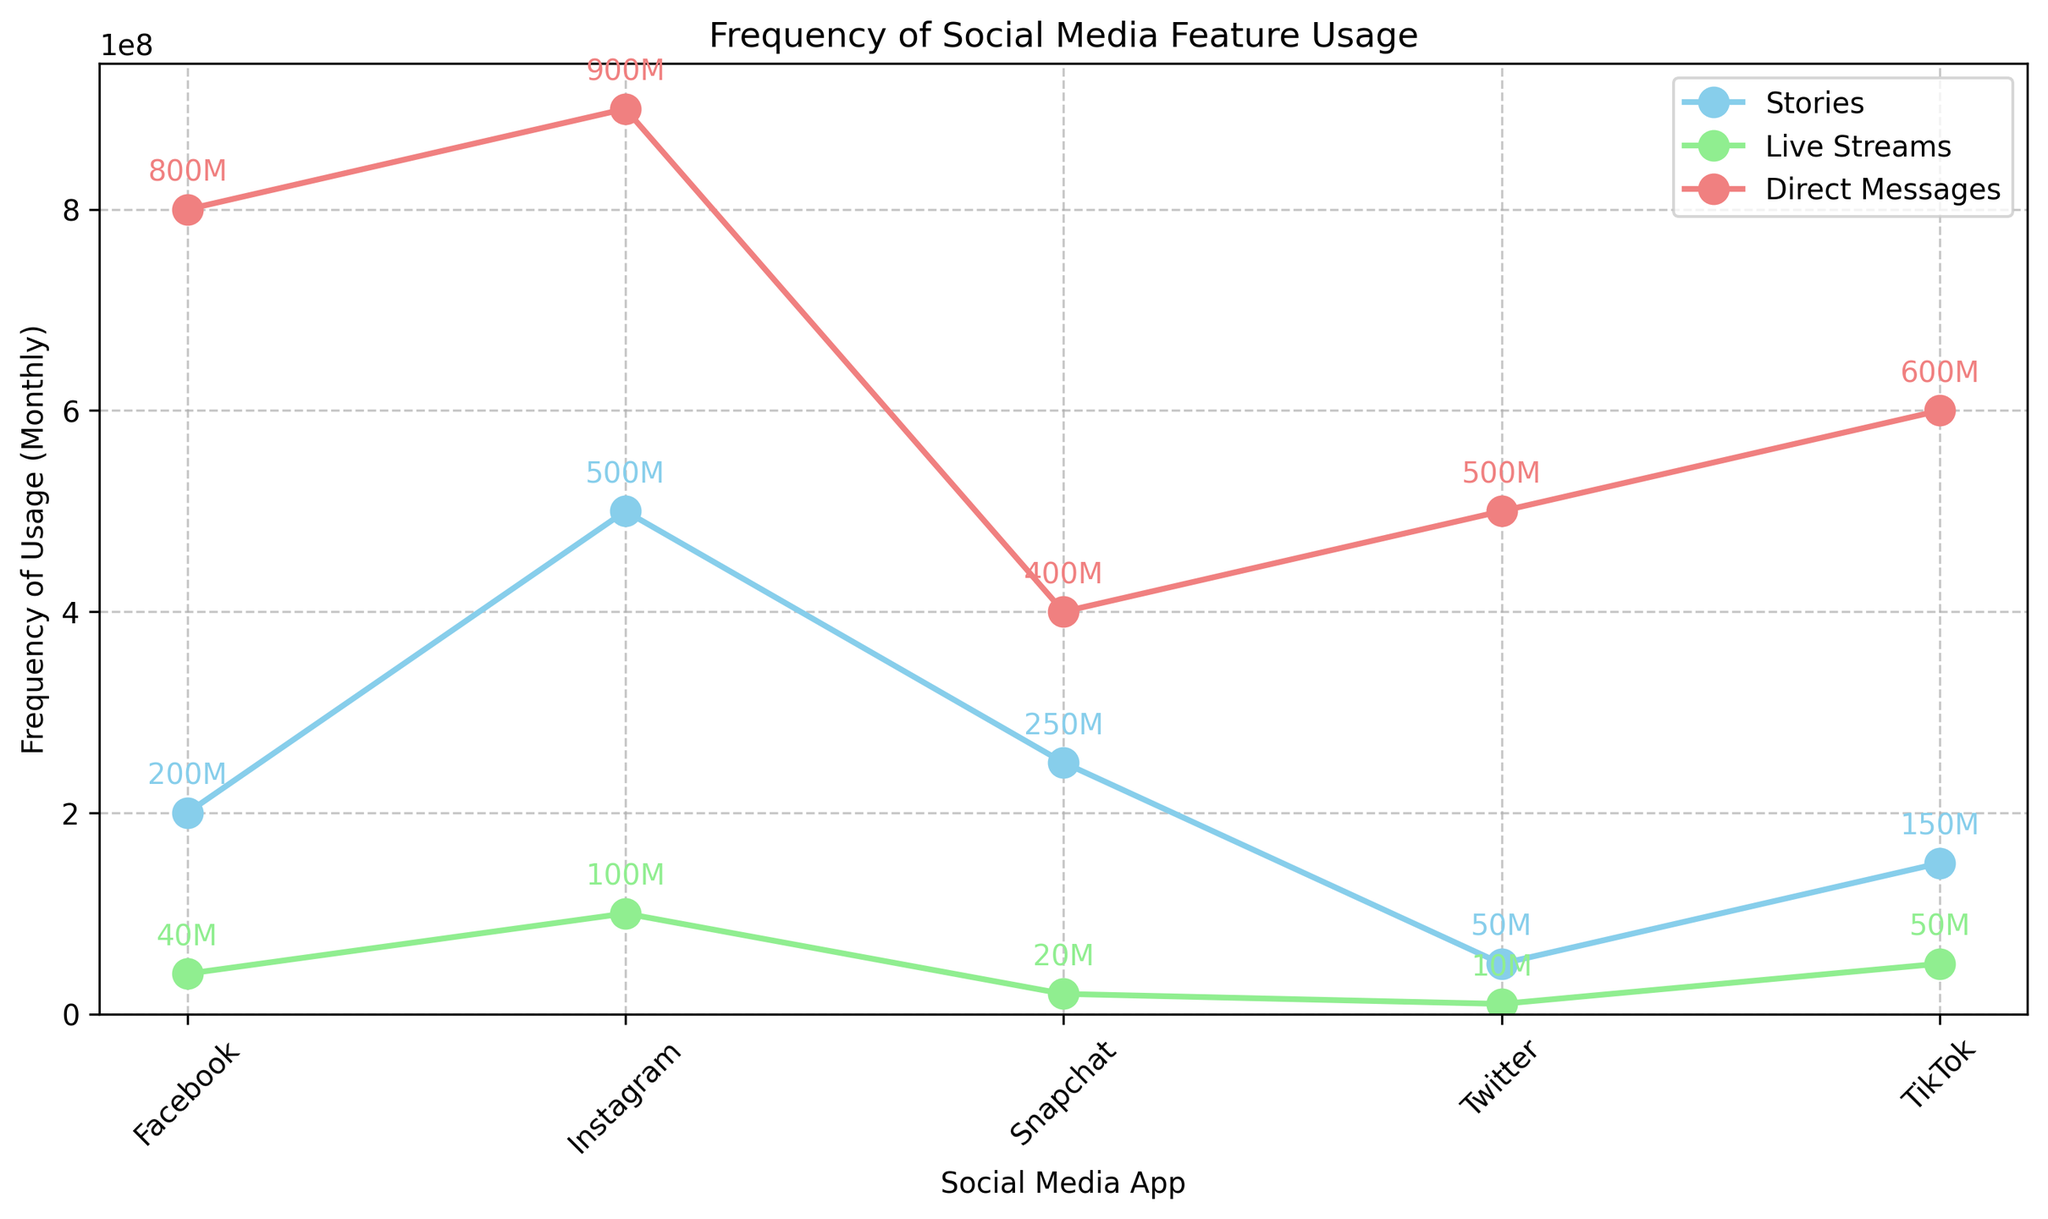What's the most frequently used feature on Instagram? Refer to the figure and identify which feature on Instagram has the highest frequency. The data shows that Direct Messages have the highest frequency of 900M.
Answer: Direct Messages Which app has the lowest frequency of Live Streams usage? Observe the Live Streams data across all social media apps. The lowest value is for Twitter with 10M monthly usage.
Answer: Twitter How much higher is Instagram's Stories usage compared to Facebook's Stories usage? Compare the Stories usage for both Instagram and Facebook. Instagram has 500M while Facebook has 200M. Subtract 200M from 500M to find the difference of 300M.
Answer: 300M Which feature has the most even distribution of usage across all the social media apps? Look at each feature's usage across all apps. Observe the patterns and variability. Direct Messages have a relatively high usage across all applications with values 800M (Facebook), 900M (Instagram), 400M (Snapchat), 500M (Twitter), 600M (TikTok).
Answer: Direct Messages Among live streams, which app shows the greatest discrepancy between Stories and Live Streams usage? Compare Stories and Live Streams usage for each app and identify the biggest difference. Facebook's Stories have 200M and Live Streams have 40M, which is a discrepancy of 160M, the highest compared to other apps.
Answer: Facebook How does the usage of Direct Messages in TikTok compare to Stories usage in Snapchat? Locate the frequencies for TikTok's Direct Messages (600M) and Snapchat's Stories (250M), and compare their values. TikTok's Direct Messages usage is more than twice that of Snapchat's Stories usage.
Answer: TikTok's Direct Messages are more frequently used What feature on Facebook has the lowest usage? Identify all features used on Facebook and compare their usage frequencies. Live Streams on Facebook have 40M usage, the lowest among the Facebook features.
Answer: Live Streams How many more millions of users use Instagram's Stories compared to Snapchat's Stories? Compare Instagram's Stories usage (500M) with Snapchat's Stories usage (250M) and subtract 250M from 500M to find the difference of 250M.
Answer: 250M What is the average frequency of Stories usage across all apps? Add up Stories usage for all apps: 200M (Facebook) + 500M (Instagram) + 250M (Snapchat) + 50M (Twitter) + 150M (TikTok) = 1150M. Divide by the number of apps (5), the average is 1150M / 5 = 230M.
Answer: 230M What is the total frequency of Live Streams usage across all social media apps? Sum up the Live Streams usage for all apps: 40M (Facebook) + 100M (Instagram) + 20M (Snapchat) + 10M (Twitter) + 50M (TikTok) = 220M.
Answer: 220M 